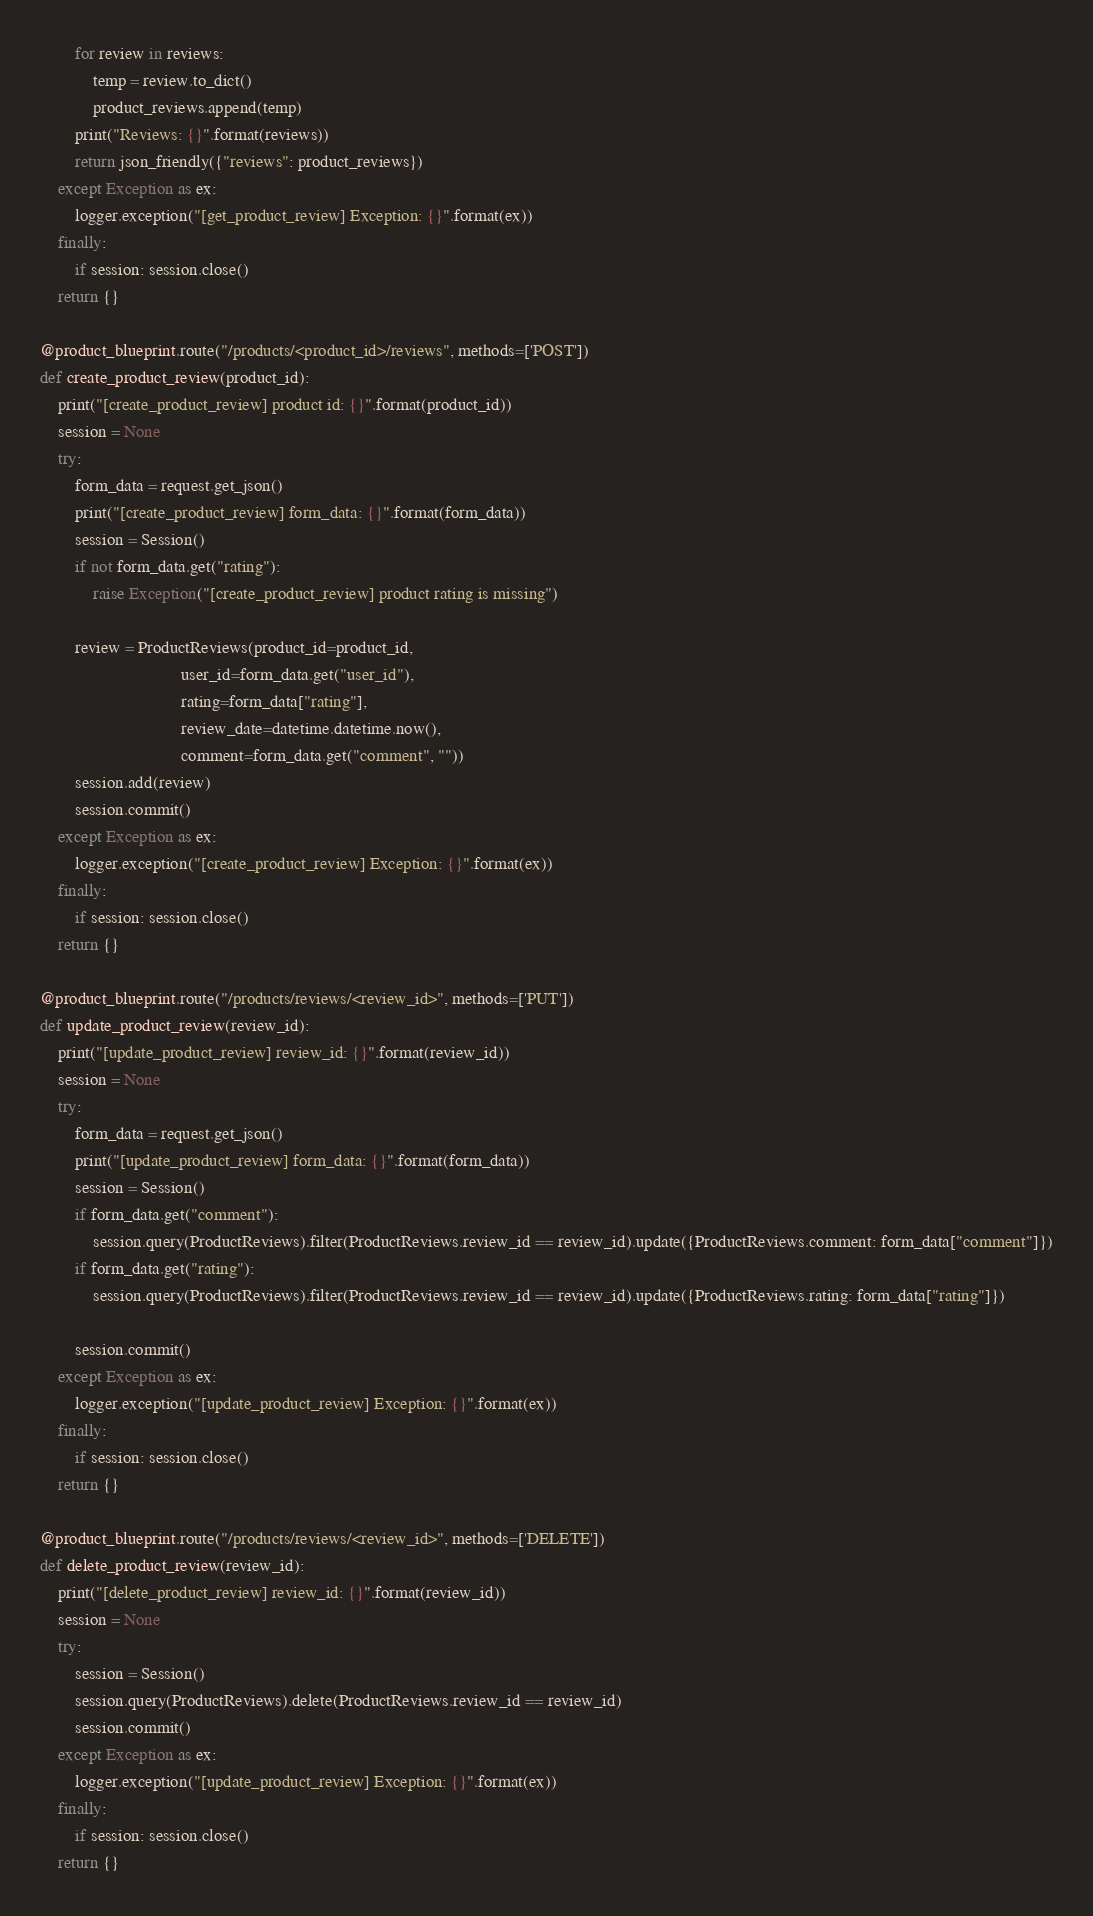<code> <loc_0><loc_0><loc_500><loc_500><_Python_>        for review in reviews:
            temp = review.to_dict()
            product_reviews.append(temp)
        print("Reviews: {}".format(reviews))
        return json_friendly({"reviews": product_reviews})
    except Exception as ex:
        logger.exception("[get_product_review] Exception: {}".format(ex))
    finally:
        if session: session.close()
    return {}
    
@product_blueprint.route("/products/<product_id>/reviews", methods=['POST'])
def create_product_review(product_id):
    print("[create_product_review] product id: {}".format(product_id))
    session = None
    try:
        form_data = request.get_json()
        print("[create_product_review] form_data: {}".format(form_data))
        session = Session()
        if not form_data.get("rating"):
            raise Exception("[create_product_review] product rating is missing")

        review = ProductReviews(product_id=product_id,
                                user_id=form_data.get("user_id"),
                                rating=form_data["rating"],
                                review_date=datetime.datetime.now(),
                                comment=form_data.get("comment", ""))
        session.add(review)
        session.commit()
    except Exception as ex:
        logger.exception("[create_product_review] Exception: {}".format(ex))
    finally:
        if session: session.close()
    return {}

@product_blueprint.route("/products/reviews/<review_id>", methods=['PUT'])
def update_product_review(review_id):
    print("[update_product_review] review_id: {}".format(review_id))
    session = None
    try:
        form_data = request.get_json()
        print("[update_product_review] form_data: {}".format(form_data))
        session = Session()
        if form_data.get("comment"):
            session.query(ProductReviews).filter(ProductReviews.review_id == review_id).update({ProductReviews.comment: form_data["comment"]})
        if form_data.get("rating"):
            session.query(ProductReviews).filter(ProductReviews.review_id == review_id).update({ProductReviews.rating: form_data["rating"]})

        session.commit()
    except Exception as ex:
        logger.exception("[update_product_review] Exception: {}".format(ex))
    finally:
        if session: session.close()
    return {}

@product_blueprint.route("/products/reviews/<review_id>", methods=['DELETE'])
def delete_product_review(review_id):
    print("[delete_product_review] review_id: {}".format(review_id))
    session = None
    try:
        session = Session()
        session.query(ProductReviews).delete(ProductReviews.review_id == review_id)
        session.commit()
    except Exception as ex:
        logger.exception("[update_product_review] Exception: {}".format(ex))
    finally:
        if session: session.close()
    return {}

</code> 